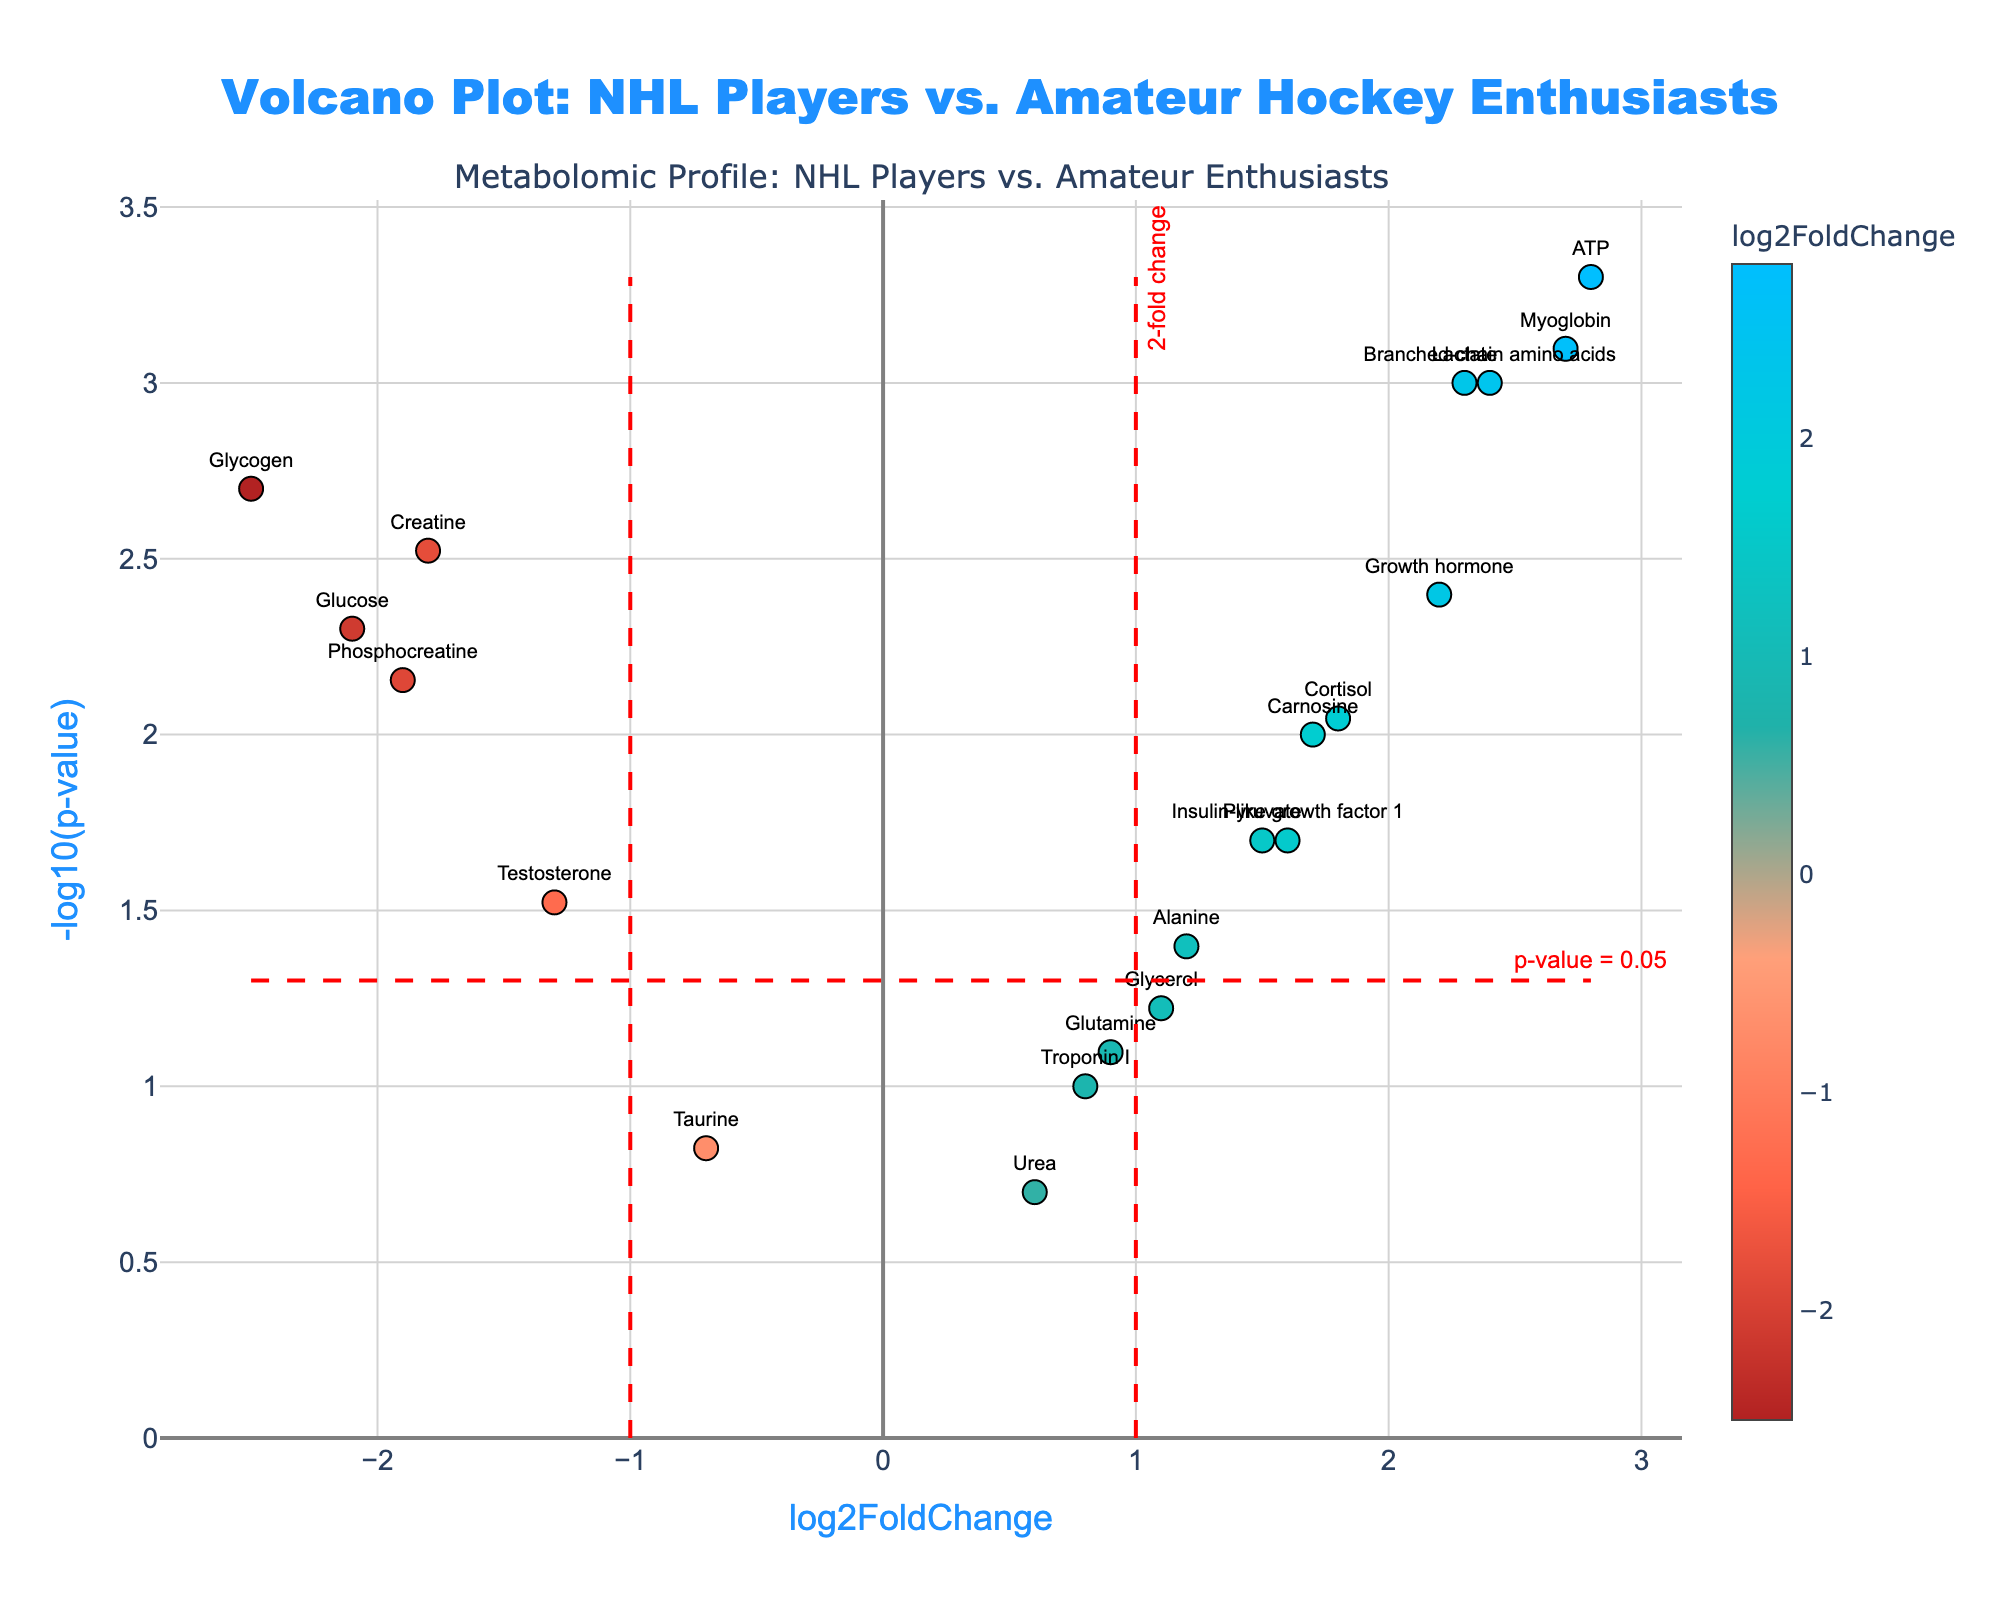Which metabolite has the highest -log10(p-value)? The highest -log10(p-value) indicates the most statistically significant metabolite. From the figure, ATP has the highest -log10(p-value) value among all metabolites.
Answer: ATP How many metabolites have a log2FoldChange greater than 0 but less than 2? We look for metabolites whose log2FoldChange values are between 0 and 2. According to the figure, there are four such metabolites: Pyruvate, Alanine, Glutamine, and Glycerol.
Answer: 4 What is the log2FoldChange threshold for significance and how many metabolites exceed it? The significance threshold for log2FoldChange is typically represented by the vertical dashed lines on the plot. In this case, the threshold is at 1 and -1. By counting the metabolites outside this range (i.e., greater than 1 or less than -1), we see that there are 10 metabolites exceeding this threshold.
Answer: 1 and 10 Which metabolite shows both a significant p-value (below 0.05) and a high positive fold change? A significant p-value corresponds to a -log10(p-value) greater than 1.3 (since -log10(0.05) = 1.3). Among the significant metabolites, we look for the highest positive log2FoldChange. The metabolite with the highest positive fold change and significant p-value is ATP.
Answer: ATP Identify the metabolites with a negative log2FoldChange and statistically significant p-values. Negative log2FoldChange indicates downregulation. For statistical significance, -log10(p-value) should be greater than 1.3. The metabolites fulfilling both criteria are Creatine, Glucose, and Phosphocreatine.
Answer: Creatine, Glucose, Phosphocreatine What can you infer about the metabolite with the lowest p-value? The lowest p-value corresponds to the highest -log10(p-value). From the figure, the metabolite with the lowest p-value is ATP, indicating a very high statistical significance in its difference between NHL players and amateurs.
Answer: ATP Are there more upregulated or downregulated metabolites with p-values below 0.05? To determine this, count the number of metabolites with positive log2FoldChange (upregulated) and -log10(p-value) > 1.3, and compare with the count of negative log2FoldChange (downregulated) and -log10(p-value) > 1.3. There are 7 upregulated metabolites and 3 downregulated ones.
Answer: Upregulated Which metabolite is closest to the significance threshold for p-value? The significance threshold for p-value is represented by the horizontal dashed red line at -log10(0.05). The metabolite closest to this line is Alanine.
Answer: Alanine 